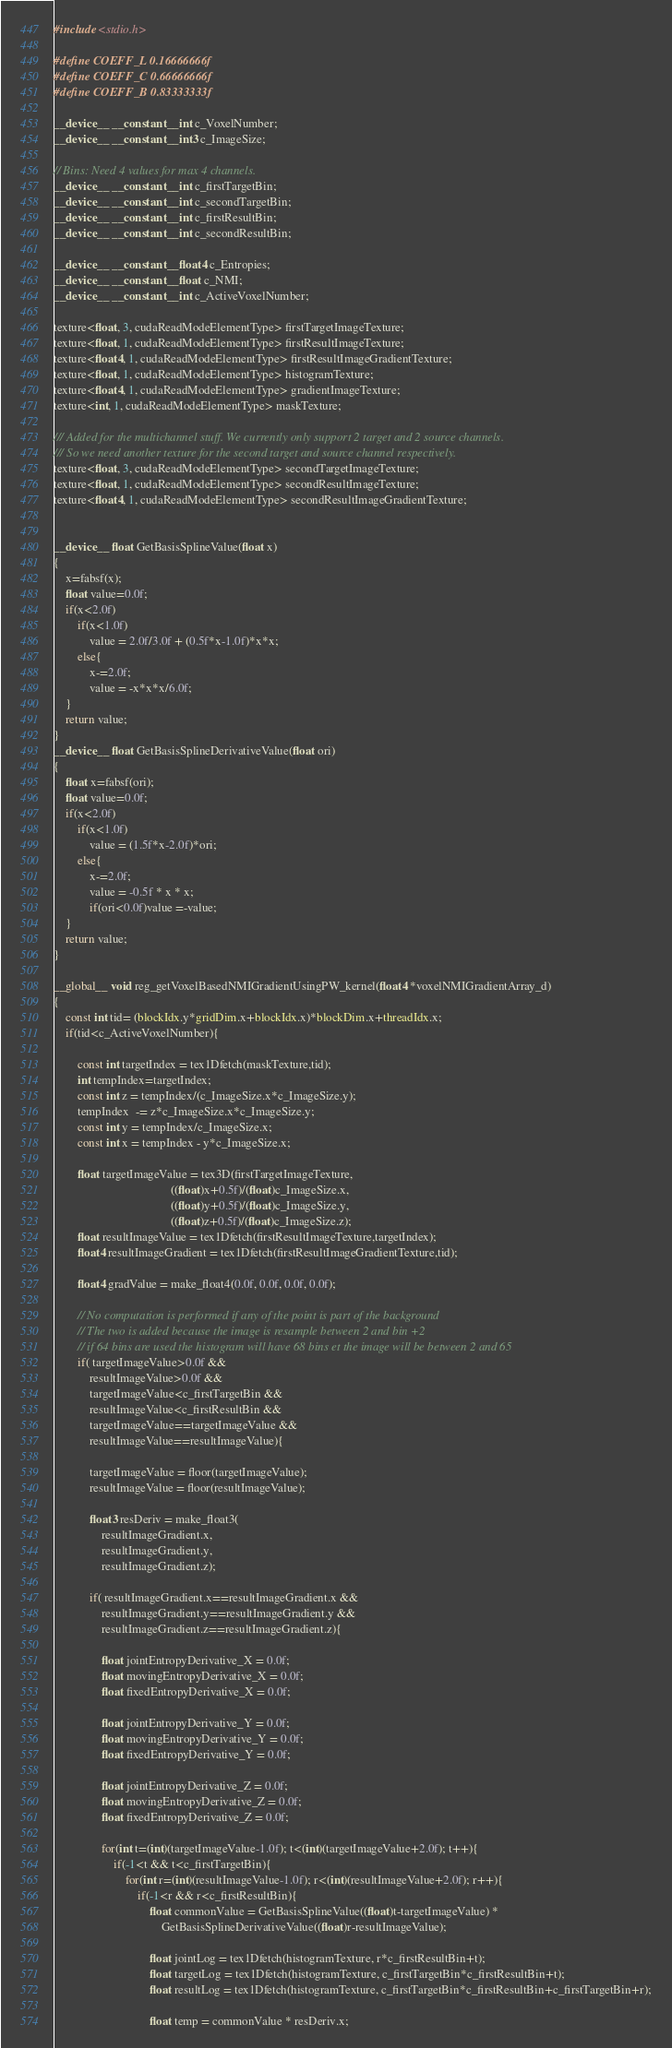Convert code to text. <code><loc_0><loc_0><loc_500><loc_500><_Cuda_>
#include <stdio.h>

#define COEFF_L 0.16666666f
#define COEFF_C 0.66666666f
#define COEFF_B 0.83333333f

__device__ __constant__ int c_VoxelNumber;
__device__ __constant__ int3 c_ImageSize;

// Bins: Need 4 values for max 4 channels.
__device__ __constant__ int c_firstTargetBin;
__device__ __constant__ int c_secondTargetBin;
__device__ __constant__ int c_firstResultBin;
__device__ __constant__ int c_secondResultBin;

__device__ __constant__ float4 c_Entropies;
__device__ __constant__ float c_NMI;
__device__ __constant__ int c_ActiveVoxelNumber;

texture<float, 3, cudaReadModeElementType> firstTargetImageTexture;
texture<float, 1, cudaReadModeElementType> firstResultImageTexture;
texture<float4, 1, cudaReadModeElementType> firstResultImageGradientTexture;
texture<float, 1, cudaReadModeElementType> histogramTexture;
texture<float4, 1, cudaReadModeElementType> gradientImageTexture;
texture<int, 1, cudaReadModeElementType> maskTexture;

/// Added for the multichannel stuff. We currently only support 2 target and 2 source channels.
/// So we need another texture for the second target and source channel respectively.
texture<float, 3, cudaReadModeElementType> secondTargetImageTexture;
texture<float, 1, cudaReadModeElementType> secondResultImageTexture;
texture<float4, 1, cudaReadModeElementType> secondResultImageGradientTexture;


__device__ float GetBasisSplineValue(float x)
{
    x=fabsf(x);
    float value=0.0f;
    if(x<2.0f)
        if(x<1.0f)
            value = 2.0f/3.0f + (0.5f*x-1.0f)*x*x;
        else{
            x-=2.0f;
            value = -x*x*x/6.0f;
    }
    return value;
}
__device__ float GetBasisSplineDerivativeValue(float ori)
{
    float x=fabsf(ori);
    float value=0.0f;
    if(x<2.0f)
        if(x<1.0f)
            value = (1.5f*x-2.0f)*ori;
        else{
            x-=2.0f;
            value = -0.5f * x * x;
            if(ori<0.0f)value =-value;
    }
    return value;
}

__global__ void reg_getVoxelBasedNMIGradientUsingPW_kernel(float4 *voxelNMIGradientArray_d)
{
    const int tid= (blockIdx.y*gridDim.x+blockIdx.x)*blockDim.x+threadIdx.x;
    if(tid<c_ActiveVoxelNumber){

        const int targetIndex = tex1Dfetch(maskTexture,tid);
        int tempIndex=targetIndex;
        const int z = tempIndex/(c_ImageSize.x*c_ImageSize.y);
        tempIndex  -= z*c_ImageSize.x*c_ImageSize.y;
        const int y = tempIndex/c_ImageSize.x;
        const int x = tempIndex - y*c_ImageSize.x;

        float targetImageValue = tex3D(firstTargetImageTexture,
                                       ((float)x+0.5f)/(float)c_ImageSize.x,
                                       ((float)y+0.5f)/(float)c_ImageSize.y,
                                       ((float)z+0.5f)/(float)c_ImageSize.z);
        float resultImageValue = tex1Dfetch(firstResultImageTexture,targetIndex);
        float4 resultImageGradient = tex1Dfetch(firstResultImageGradientTexture,tid);

        float4 gradValue = make_float4(0.0f, 0.0f, 0.0f, 0.0f);

        // No computation is performed if any of the point is part of the background
        // The two is added because the image is resample between 2 and bin +2
        // if 64 bins are used the histogram will have 68 bins et the image will be between 2 and 65
        if( targetImageValue>0.0f &&
            resultImageValue>0.0f &&
            targetImageValue<c_firstTargetBin &&
            resultImageValue<c_firstResultBin &&
            targetImageValue==targetImageValue &&
            resultImageValue==resultImageValue){

            targetImageValue = floor(targetImageValue);
            resultImageValue = floor(resultImageValue);

            float3 resDeriv = make_float3(
                resultImageGradient.x,
                resultImageGradient.y,
                resultImageGradient.z);

            if( resultImageGradient.x==resultImageGradient.x &&
                resultImageGradient.y==resultImageGradient.y &&
                resultImageGradient.z==resultImageGradient.z){

                float jointEntropyDerivative_X = 0.0f;
                float movingEntropyDerivative_X = 0.0f;
                float fixedEntropyDerivative_X = 0.0f;

                float jointEntropyDerivative_Y = 0.0f;
                float movingEntropyDerivative_Y = 0.0f;
                float fixedEntropyDerivative_Y = 0.0f;

                float jointEntropyDerivative_Z = 0.0f;
                float movingEntropyDerivative_Z = 0.0f;
                float fixedEntropyDerivative_Z = 0.0f;

                for(int t=(int)(targetImageValue-1.0f); t<(int)(targetImageValue+2.0f); t++){
                    if(-1<t && t<c_firstTargetBin){
                        for(int r=(int)(resultImageValue-1.0f); r<(int)(resultImageValue+2.0f); r++){
                            if(-1<r && r<c_firstResultBin){
                                float commonValue = GetBasisSplineValue((float)t-targetImageValue) *
                                    GetBasisSplineDerivativeValue((float)r-resultImageValue);

                                float jointLog = tex1Dfetch(histogramTexture, r*c_firstResultBin+t);
                                float targetLog = tex1Dfetch(histogramTexture, c_firstTargetBin*c_firstResultBin+t);
                                float resultLog = tex1Dfetch(histogramTexture, c_firstTargetBin*c_firstResultBin+c_firstTargetBin+r);

                                float temp = commonValue * resDeriv.x;</code> 